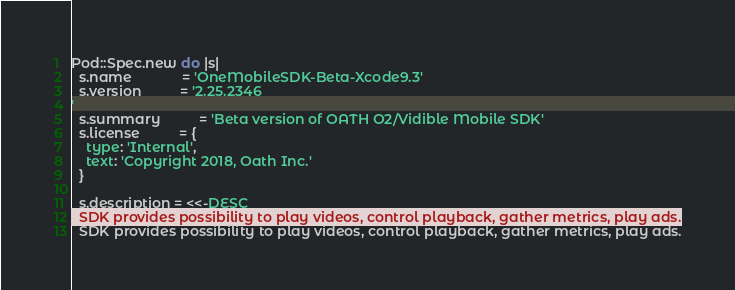<code> <loc_0><loc_0><loc_500><loc_500><_Ruby_>Pod::Spec.new do |s|
  s.name             = 'OneMobileSDK-Beta-Xcode9.3'
  s.version          = '2.25.2346
'
  s.summary          = 'Beta version of OATH O2/Vidible Mobile SDK'
  s.license          = {
    type: 'Internal',
    text: 'Copyright 2018, Oath Inc.'
  }

  s.description = <<-DESC
  SDK provides possibility to play videos, control playback, gather metrics, play ads.</code> 